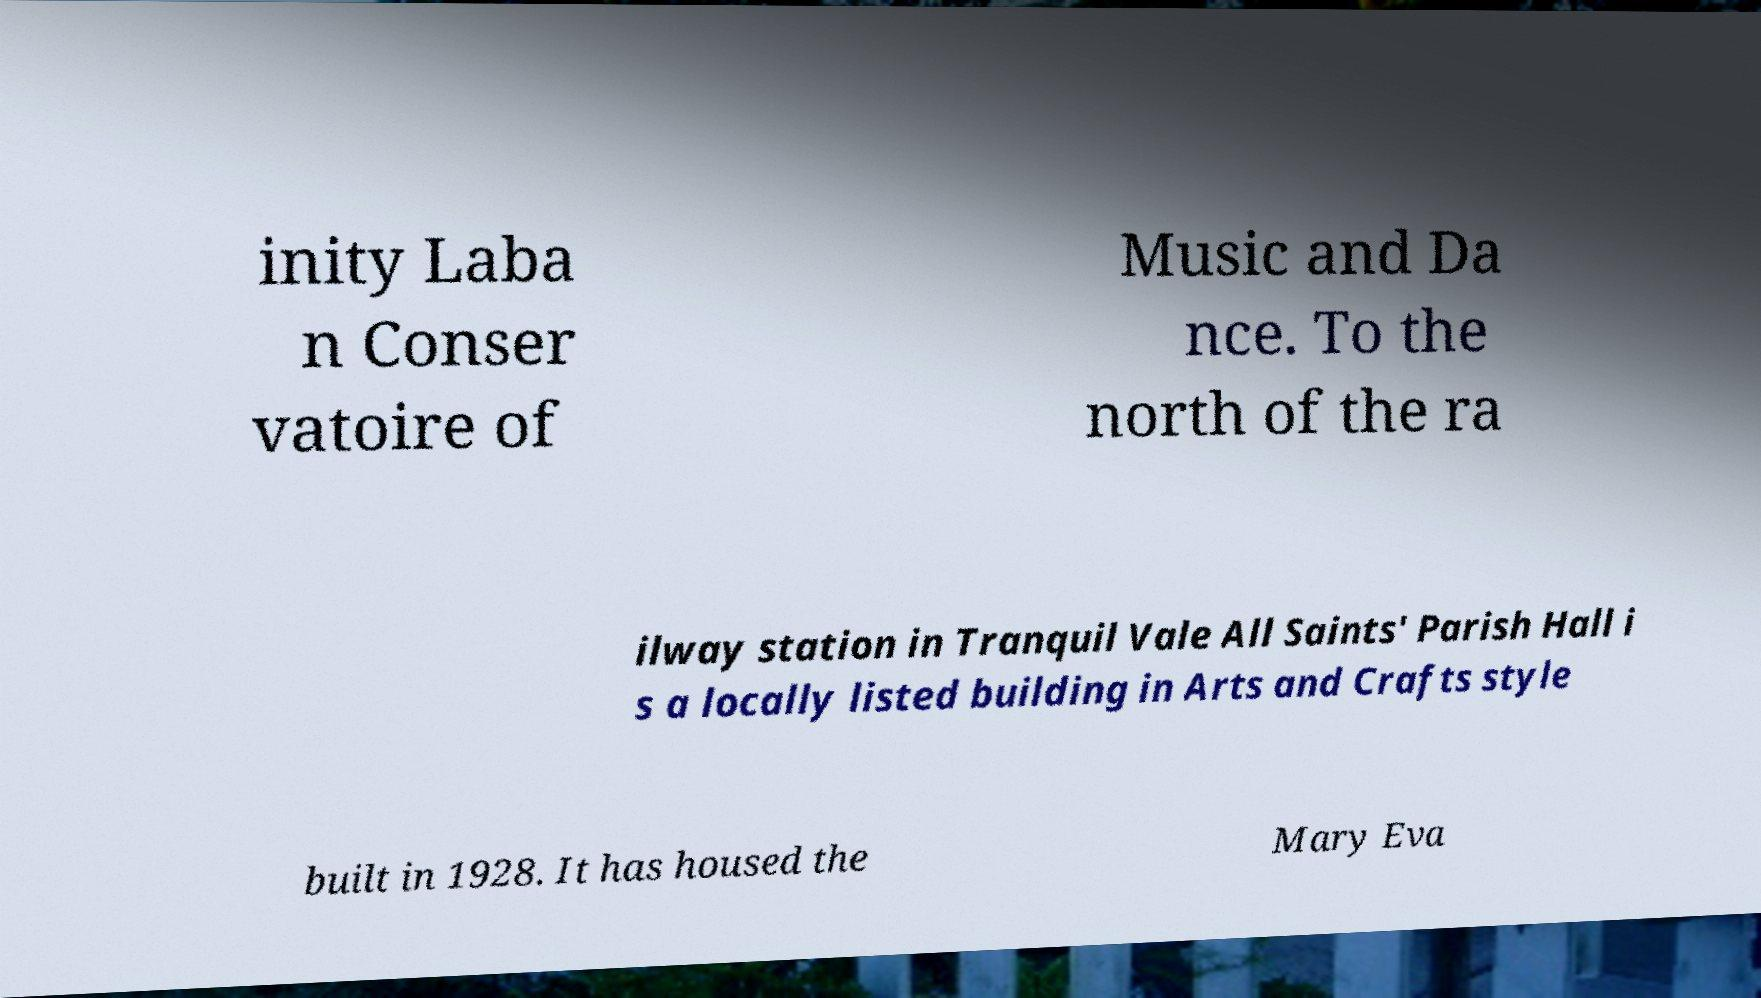For documentation purposes, I need the text within this image transcribed. Could you provide that? inity Laba n Conser vatoire of Music and Da nce. To the north of the ra ilway station in Tranquil Vale All Saints' Parish Hall i s a locally listed building in Arts and Crafts style built in 1928. It has housed the Mary Eva 